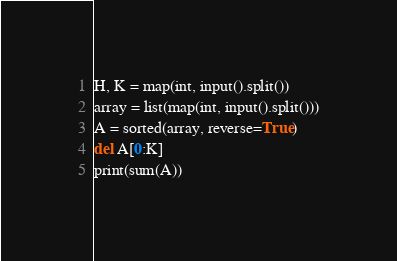<code> <loc_0><loc_0><loc_500><loc_500><_Python_>H, K = map(int, input().split())
array = list(map(int, input().split()))
A = sorted(array, reverse=True)
del A[0:K]
print(sum(A))</code> 